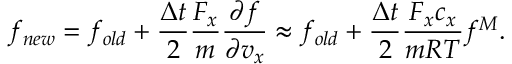<formula> <loc_0><loc_0><loc_500><loc_500>f _ { n e w } = f _ { o l d } + \frac { \Delta t } { 2 } \frac { F _ { x } } { m } \frac { \partial f } { \partial v _ { x } } \approx f _ { o l d } + \frac { \Delta t } { 2 } \frac { F _ { x } c _ { x } } { m R T } f ^ { M } .</formula> 